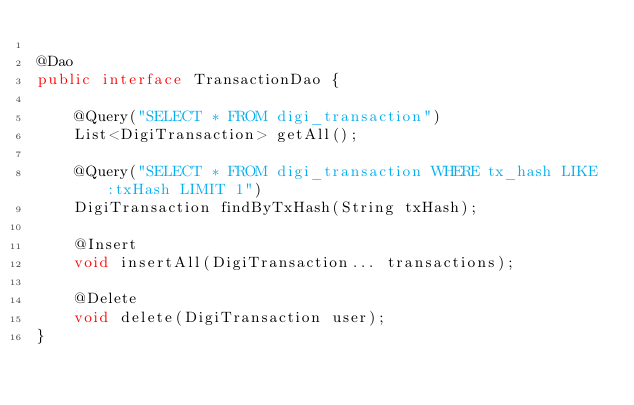<code> <loc_0><loc_0><loc_500><loc_500><_Java_>
@Dao
public interface TransactionDao {

    @Query("SELECT * FROM digi_transaction")
    List<DigiTransaction> getAll();

    @Query("SELECT * FROM digi_transaction WHERE tx_hash LIKE :txHash LIMIT 1")
    DigiTransaction findByTxHash(String txHash);

    @Insert
    void insertAll(DigiTransaction... transactions);

    @Delete
    void delete(DigiTransaction user);
}</code> 